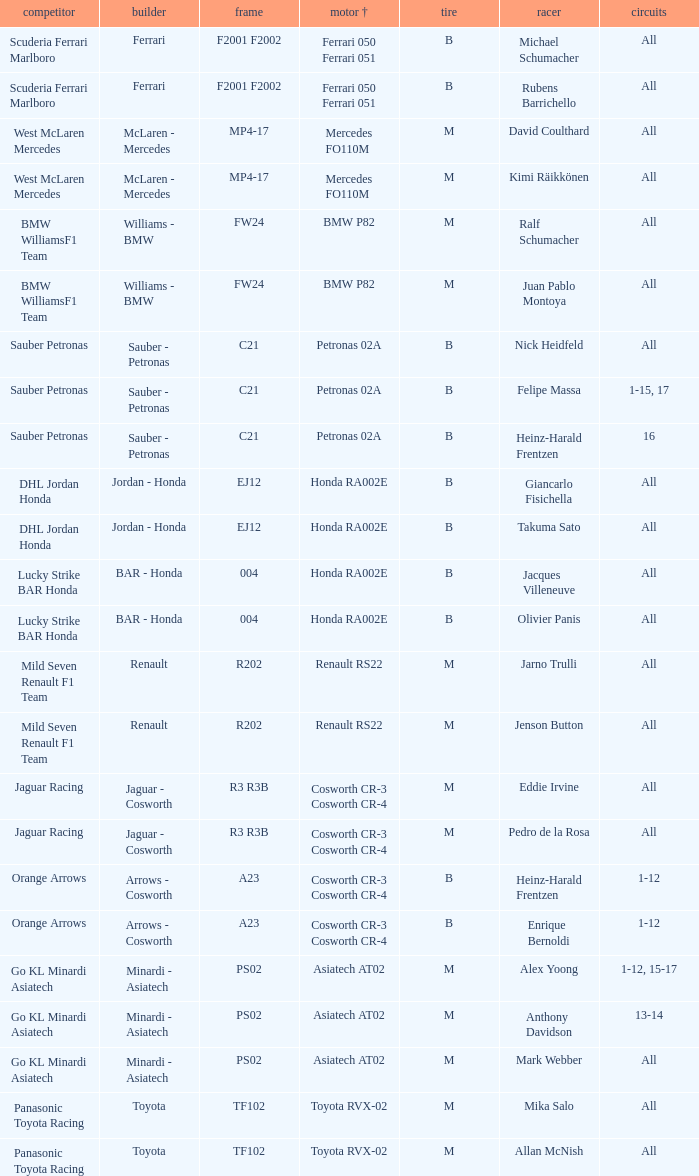Who operates the vehicle with a mercedes fo110m engine? David Coulthard, Kimi Räikkönen. 